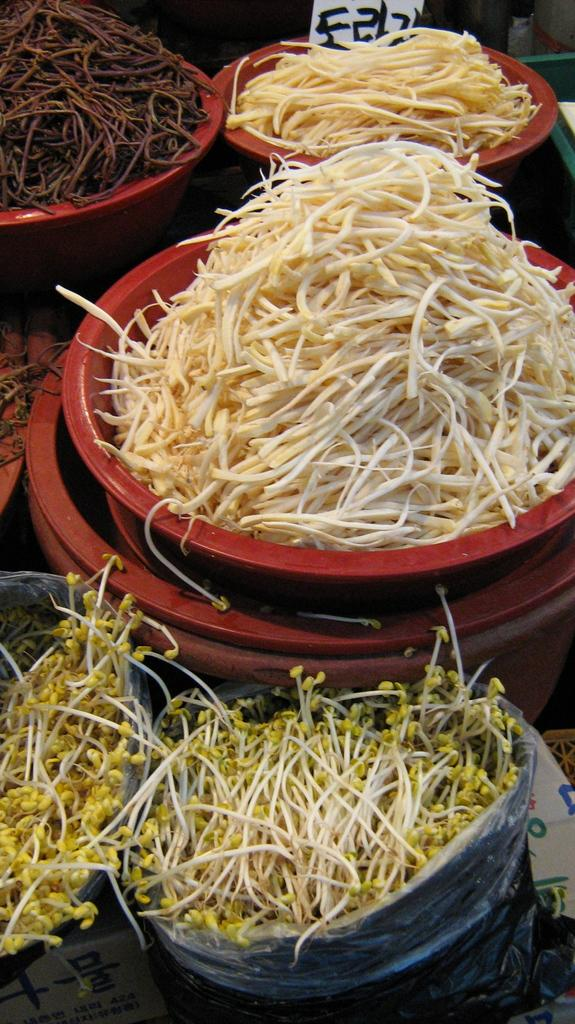What is covered by the plastic in the image? There is a plastic cover in the image, and sprouts are inside it. What else can be seen in the image besides the plastic cover? There are containers in the image. What is inside the containers? There are food items in the containers. How does the plastic cover react to someone sneezing in the image? There is no sneezing or reaction to a sneeze in the image; it only shows a plastic cover with sprouts inside and containers with food items. 